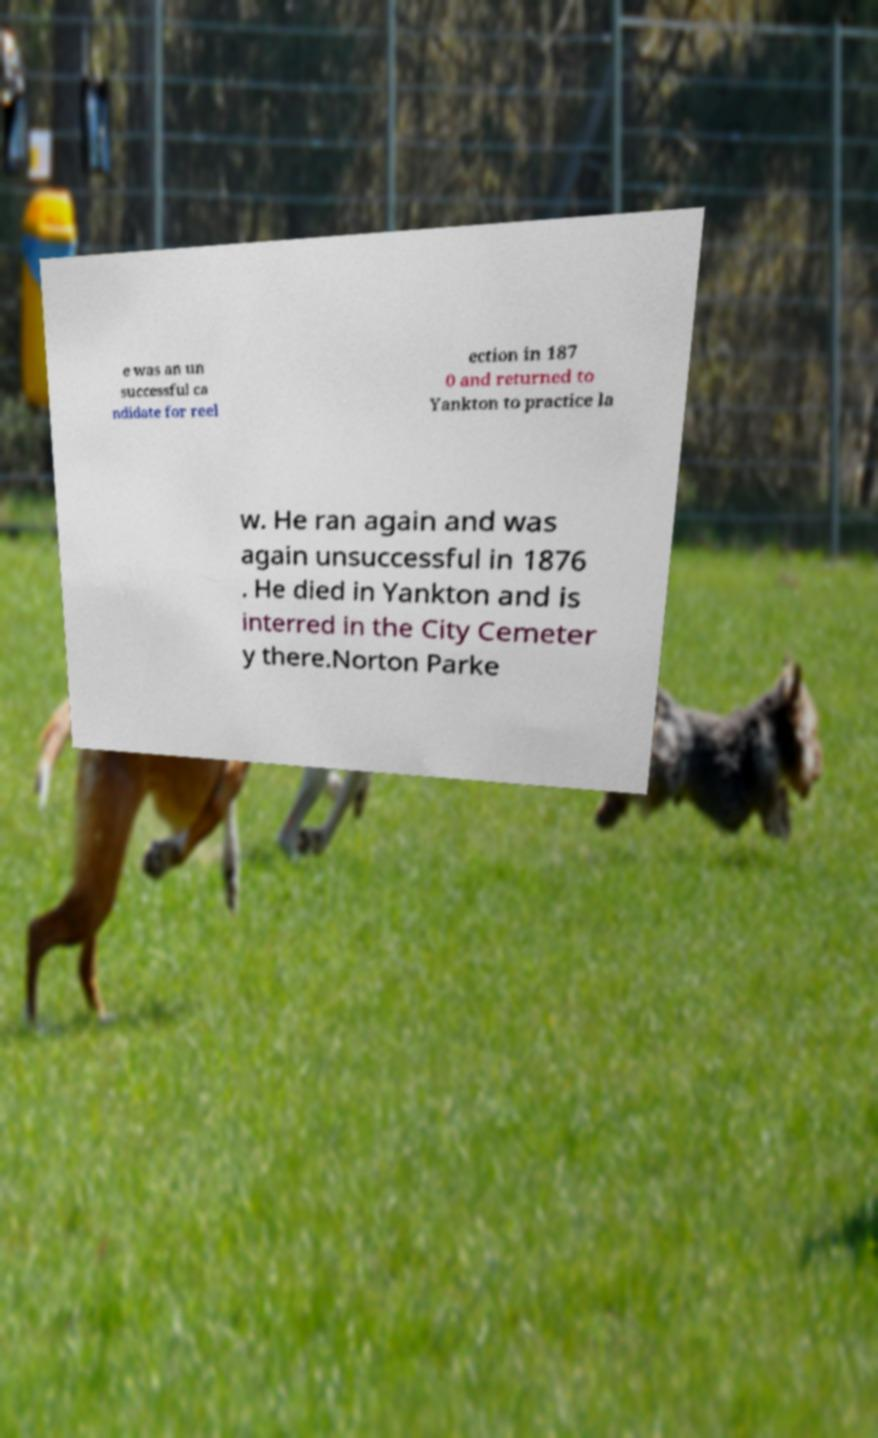For documentation purposes, I need the text within this image transcribed. Could you provide that? e was an un successful ca ndidate for reel ection in 187 0 and returned to Yankton to practice la w. He ran again and was again unsuccessful in 1876 . He died in Yankton and is interred in the City Cemeter y there.Norton Parke 